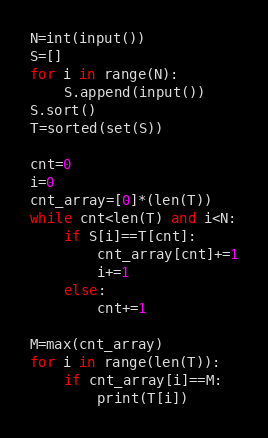<code> <loc_0><loc_0><loc_500><loc_500><_Python_>N=int(input())
S=[]
for i in range(N):
    S.append(input())
S.sort()
T=sorted(set(S))

cnt=0
i=0
cnt_array=[0]*(len(T))
while cnt<len(T) and i<N:
    if S[i]==T[cnt]:
        cnt_array[cnt]+=1
        i+=1
    else:
        cnt+=1

M=max(cnt_array)
for i in range(len(T)):
    if cnt_array[i]==M:
        print(T[i])</code> 